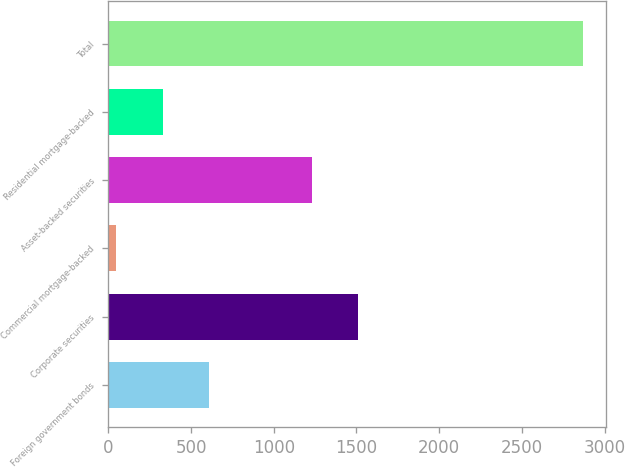Convert chart to OTSL. <chart><loc_0><loc_0><loc_500><loc_500><bar_chart><fcel>Foreign government bonds<fcel>Corporate securities<fcel>Commercial mortgage-backed<fcel>Asset-backed securities<fcel>Residential mortgage-backed<fcel>Total<nl><fcel>611<fcel>1511<fcel>47<fcel>1229<fcel>329<fcel>2867<nl></chart> 